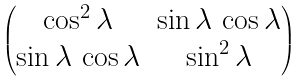Convert formula to latex. <formula><loc_0><loc_0><loc_500><loc_500>\begin{pmatrix} \cos ^ { 2 } \lambda & \sin \lambda \, \cos \lambda \\ \sin \lambda \, \cos \lambda & \sin ^ { 2 } \lambda \end{pmatrix}</formula> 